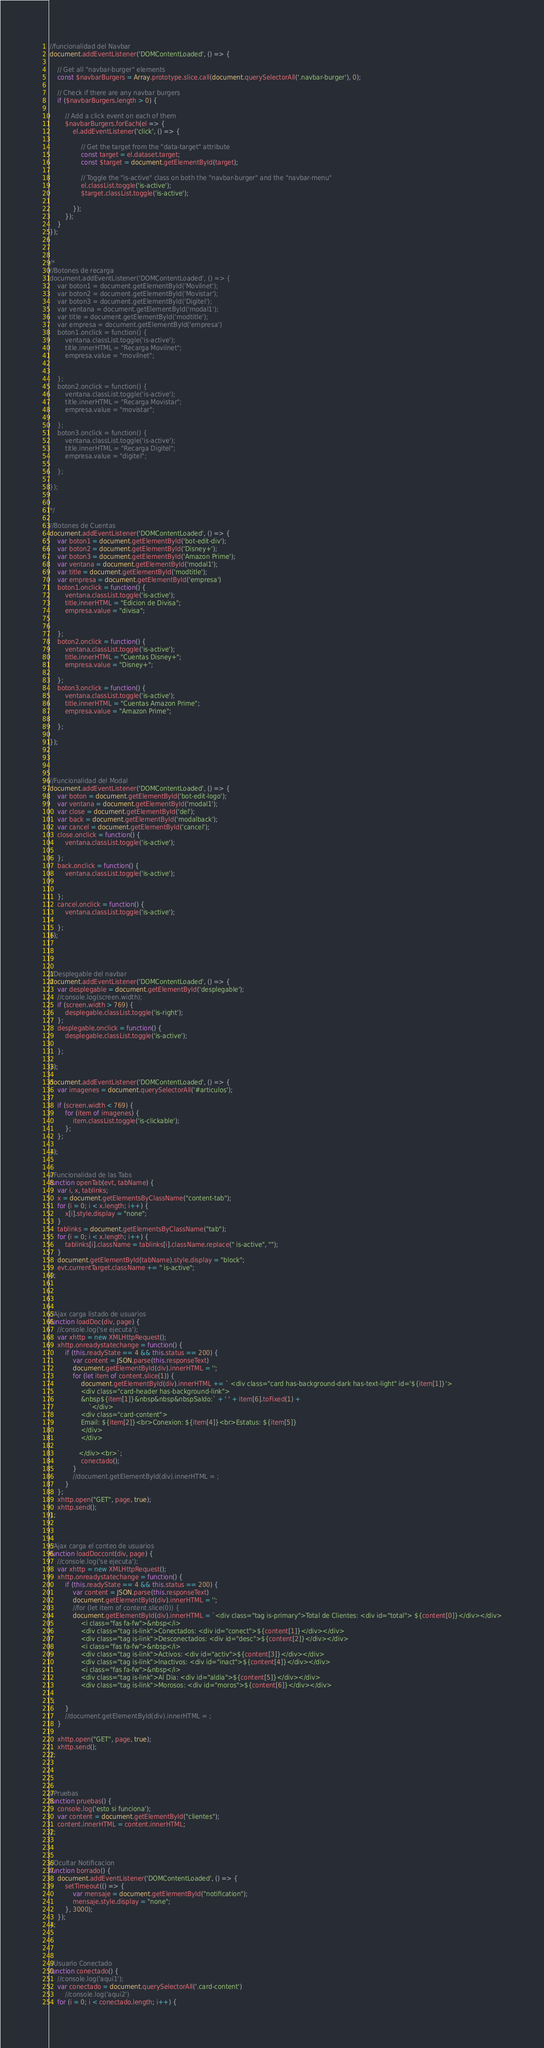Convert code to text. <code><loc_0><loc_0><loc_500><loc_500><_JavaScript_>//funcionalidad del Navbar
document.addEventListener('DOMContentLoaded', () => {

    // Get all "navbar-burger" elements
    const $navbarBurgers = Array.prototype.slice.call(document.querySelectorAll('.navbar-burger'), 0);

    // Check if there are any navbar burgers
    if ($navbarBurgers.length > 0) {

        // Add a click event on each of them
        $navbarBurgers.forEach(el => {
            el.addEventListener('click', () => {

                // Get the target from the "data-target" attribute
                const target = el.dataset.target;
                const $target = document.getElementById(target);

                // Toggle the "is-active" class on both the "navbar-burger" and the "navbar-menu"
                el.classList.toggle('is-active');
                $target.classList.toggle('is-active');

            });
        });
    }
});



/*
//Botones de recarga
document.addEventListener('DOMContentLoaded', () => {
    var boton1 = document.getElementById('Movilnet');
    var boton2 = document.getElementById('Movistar');
    var boton3 = document.getElementById('Digitel');
    var ventana = document.getElementById('modal1');
    var title = document.getElementById('modtitle');
    var empresa = document.getElementById('empresa')
    boton1.onclick = function() {
        ventana.classList.toggle('is-active');
        title.innerHTML = "Recarga Movilnet";
        empresa.value = "movilnet";


    };
    boton2.onclick = function() {
        ventana.classList.toggle('is-active');
        title.innerHTML = "Recarga Movistar";
        empresa.value = "movistar";

    };
    boton3.onclick = function() {
        ventana.classList.toggle('is-active');
        title.innerHTML = "Recarga Digitel";
        empresa.value = "digitel";

    };

});


*/

//Botones de Cuentas
document.addEventListener('DOMContentLoaded', () => {
    var boton1 = document.getElementById('bot-edit-div');
    var boton2 = document.getElementById('Disney+');
    var boton3 = document.getElementById('Amazon Prime');
    var ventana = document.getElementById('modal1');
    var title = document.getElementById('modtitle');
    var empresa = document.getElementById('empresa')
    boton1.onclick = function() {
        ventana.classList.toggle('is-active');
        title.innerHTML = "Edicion de Divisa";
        empresa.value = "divisa";


    };
    boton2.onclick = function() {
        ventana.classList.toggle('is-active');
        title.innerHTML = "Cuentas Disney+";
        empresa.value = "Disney+";

    };
    boton3.onclick = function() {
        ventana.classList.toggle('is-active');
        title.innerHTML = "Cuentas Amazon Prime";
        empresa.value = "Amazon Prime";

    };

});




//Funcionalidad del Modal
document.addEventListener('DOMContentLoaded', () => {
    var boton = document.getElementById('bot-edit-logo');
    var ventana = document.getElementById('modal1');
    var close = document.getElementById('del');
    var back = document.getElementById('modalback');
    var cancel = document.getElementById('cancel');
    close.onclick = function() {
        ventana.classList.toggle('is-active');

    };
    back.onclick = function() {
        ventana.classList.toggle('is-active');


    };
    cancel.onclick = function() {
        ventana.classList.toggle('is-active');

    };
});




//Desplegable del navbar
document.addEventListener('DOMContentLoaded', () => {
    var desplegable = document.getElementById('desplegable');
    //console.log(screen.width);
    if (screen.width > 769) {
        desplegable.classList.toggle('is-right');
    };
    desplegable.onclick = function() {
        desplegable.classList.toggle('is-active');

    };

});

document.addEventListener('DOMContentLoaded', () => {
    var imagenes = document.querySelectorAll('#articulos');

    if (screen.width < 769) {
        for (item of imagenes) {
            item.classList.toggle('is-clickable');
        };
    };

});


//Funcionalidad de las Tabs
function openTab(evt, tabName) {
    var i, x, tablinks;
    x = document.getElementsByClassName("content-tab");
    for (i = 0; i < x.length; i++) {
        x[i].style.display = "none";
    }
    tablinks = document.getElementsByClassName("tab");
    for (i = 0; i < x.length; i++) {
        tablinks[i].className = tablinks[i].className.replace(" is-active", "");
    }
    document.getElementById(tabName).style.display = "block";
    evt.currentTarget.className += " is-active";
};




//Ajax carga listado de usuarios
function loadDoc(div, page) {
    //console.log('se ejecuta');
    var xhttp = new XMLHttpRequest();
    xhttp.onreadystatechange = function() {
        if (this.readyState == 4 && this.status == 200) {
            var content = JSON.parse(this.responseText)
            document.getElementById(div).innerHTML = '';
            for (let item of content.slice(1)) {
                document.getElementById(div).innerHTML += ` <div class="card has-background-dark has-text-light" id='${item[1]}'>
                <div class="card-header has-background-link">
                &nbsp${item[1]}&nbsp&nbsp&nbspSaldo:` + ' ' + item[6].toFixed(1) +
                    `</div>
                <div class="card-content">
                Email: ${item[2]}<br>Conexion: ${item[4]}<br>Estatus: ${item[5]}
                </div>
                </div>

               </div><br>`;
                conectado();
            }
            //document.getElementById(div).innerHTML = ;
        }
    };
    xhttp.open("GET", page, true);
    xhttp.send();
};



//Ajax carga el conteo de usuarios
function loadDoccont(div, page) {
    //console.log('se ejecuta');
    var xhttp = new XMLHttpRequest();
    xhttp.onreadystatechange = function() {
        if (this.readyState == 4 && this.status == 200) {
            var content = JSON.parse(this.responseText)
            document.getElementById(div).innerHTML = '';
            //for (let item of content.slice(0)) {
            document.getElementById(div).innerHTML = `<div class="tag is-primary">Total de Clientes: <div id="total"> ${content[0]}</div></div>
                <i class="fas fa-fw">&nbsp</i>
                <div class="tag is-link">Conectados: <div id="conect">${content[1]}</div></div>
                <div class="tag is-link">Desconectados: <div id="desc">${content[2]}</div></div>
                <i class="fas fa-fw">&nbsp</i>
                <div class="tag is-link">Activos: <div id="activ">${content[3]}</div></div>
                <div class="tag is-link">Inactivos: <div id="inact">${content[4]}</div></div>
                <i class="fas fa-fw">&nbsp</i>
                <div class="tag is-link">Al Dia: <div id="aldia">${content[5]}</div></div>
                <div class="tag is-link">Morosos: <div id="moros">${content[6]}</div></div>

`;
        }
        //document.getElementById(div).innerHTML = ;
    }

    xhttp.open("GET", page, true);
    xhttp.send();
};




//Pruebas
function pruebas() {
    console.log('esto si funciona');
    var content = document.getElementById("clientes");
    content.innerHTML = content.innerHTML;
};



//Ocultar Notificacion
function borrado() {
    document.addEventListener('DOMContentLoaded', () => {
        setTimeout(() => {
            var mensaje = document.getElementById("notification");
            mensaje.style.display = "none";
        }, 3000);
    });
};




//Usuario Conectado
function conectado() {
    //console.log('aqui1');
    var conectado = document.querySelectorAll('.card-content')
        //console.log('aqui2')
    for (i = 0; i < conectado.length; i++) {</code> 